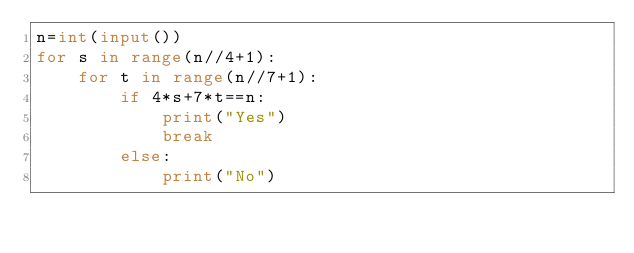Convert code to text. <code><loc_0><loc_0><loc_500><loc_500><_Python_>n=int(input())
for s in range(n//4+1):
    for t in range(n//7+1):
        if 4*s+7*t==n:
            print("Yes")
            break
        else:
            print("No")</code> 